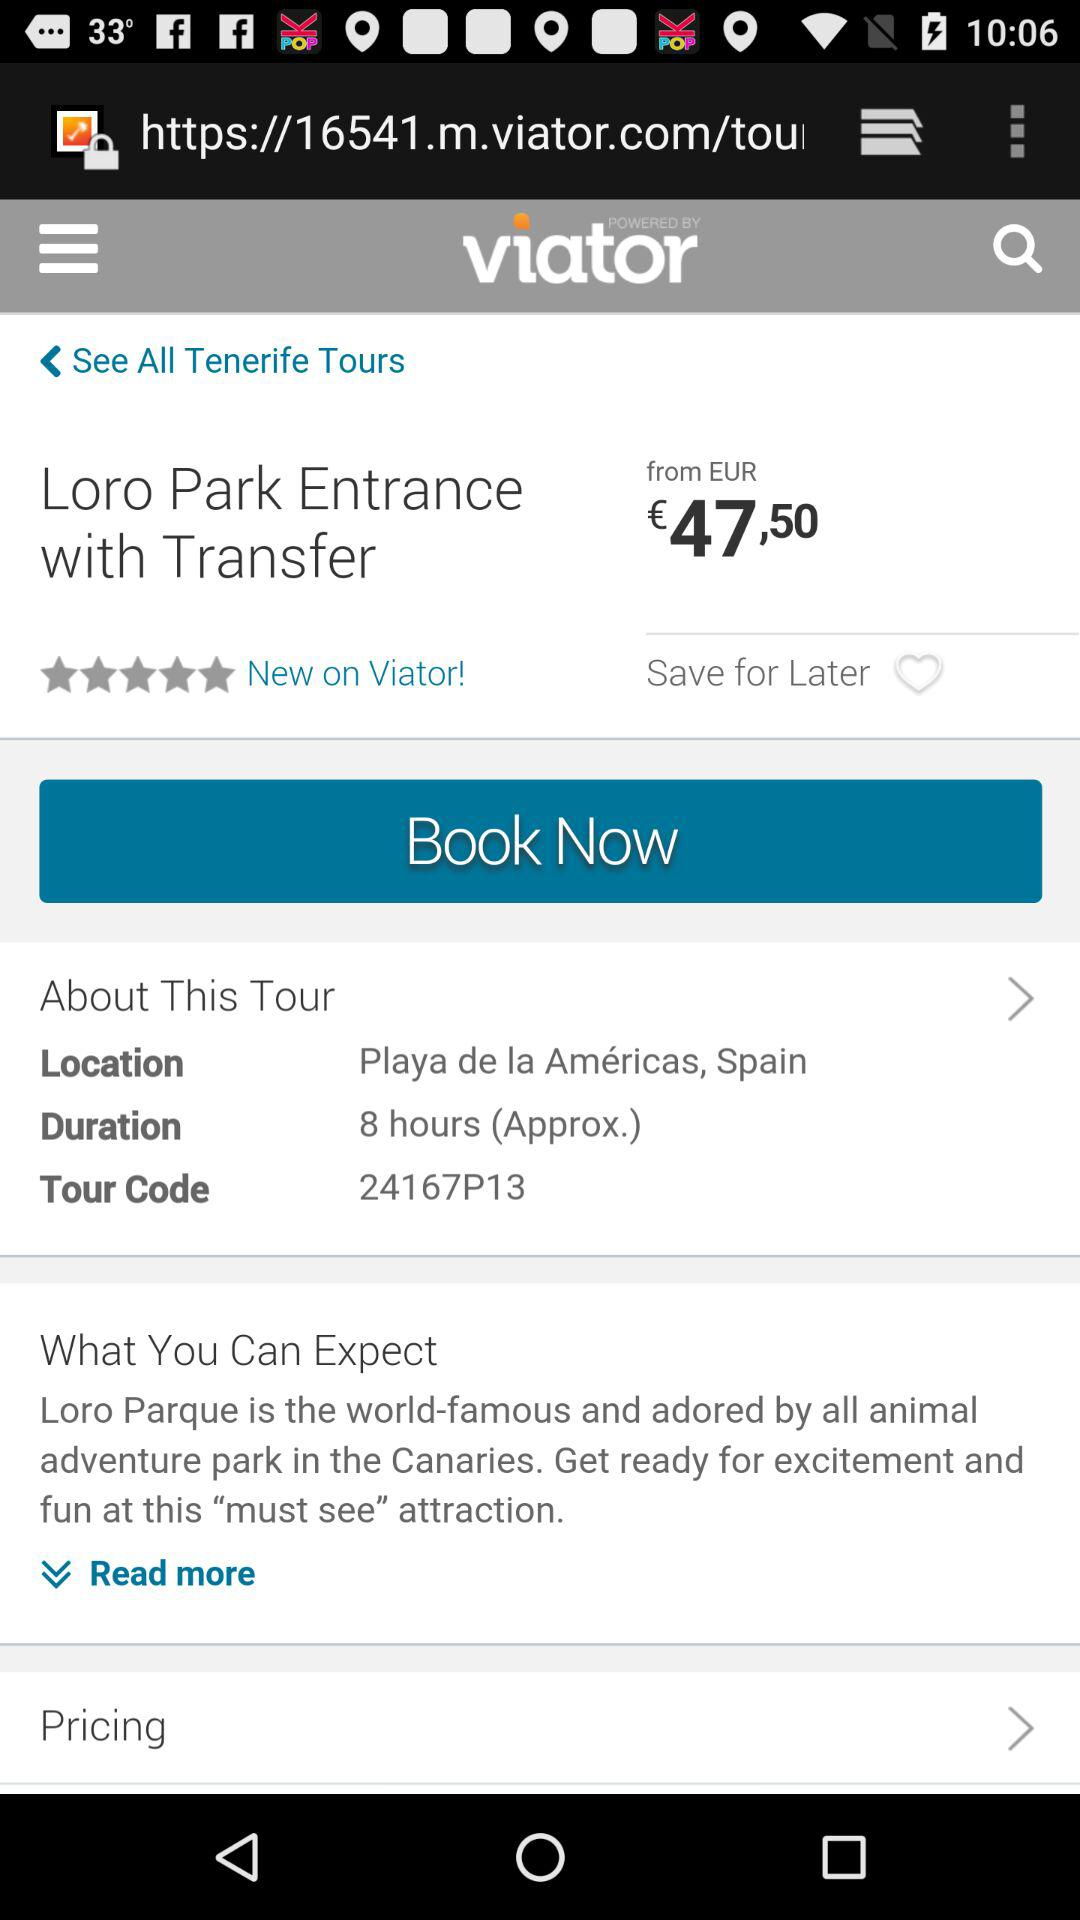How many stars are given to "Loro Park"? There are 5 stars given to "Loro Park". 